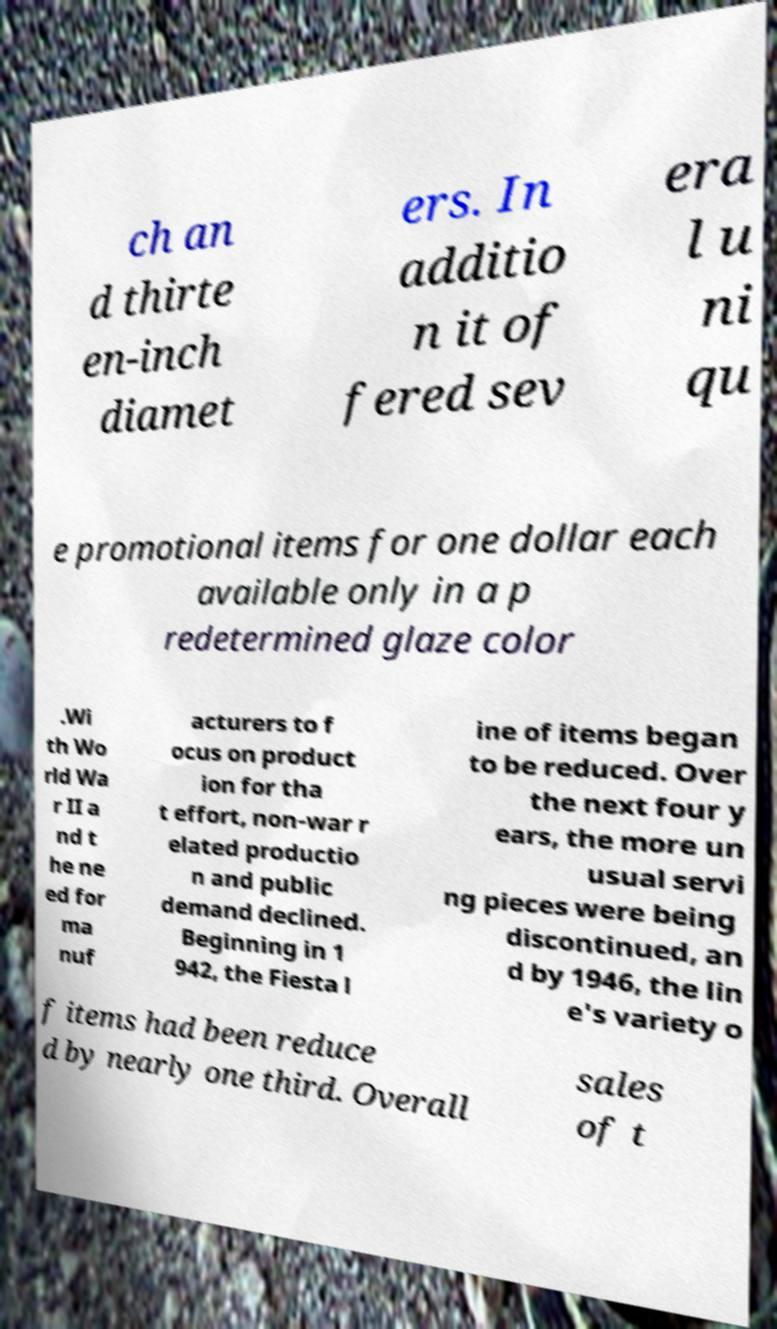Could you extract and type out the text from this image? ch an d thirte en-inch diamet ers. In additio n it of fered sev era l u ni qu e promotional items for one dollar each available only in a p redetermined glaze color .Wi th Wo rld Wa r II a nd t he ne ed for ma nuf acturers to f ocus on product ion for tha t effort, non-war r elated productio n and public demand declined. Beginning in 1 942, the Fiesta l ine of items began to be reduced. Over the next four y ears, the more un usual servi ng pieces were being discontinued, an d by 1946, the lin e's variety o f items had been reduce d by nearly one third. Overall sales of t 